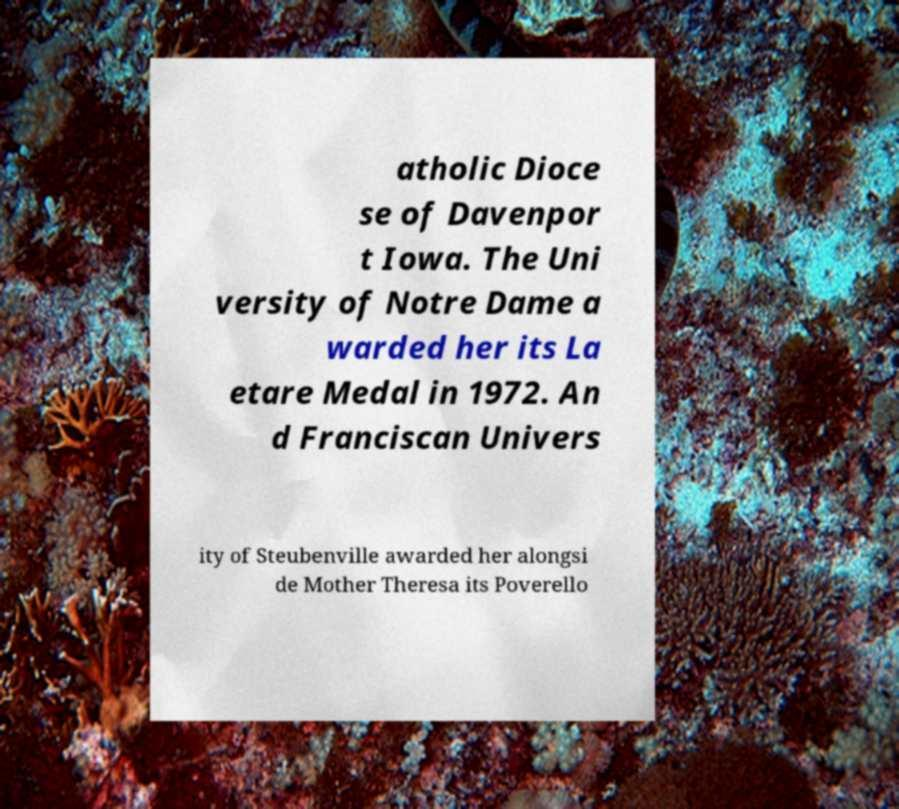For documentation purposes, I need the text within this image transcribed. Could you provide that? atholic Dioce se of Davenpor t Iowa. The Uni versity of Notre Dame a warded her its La etare Medal in 1972. An d Franciscan Univers ity of Steubenville awarded her alongsi de Mother Theresa its Poverello 